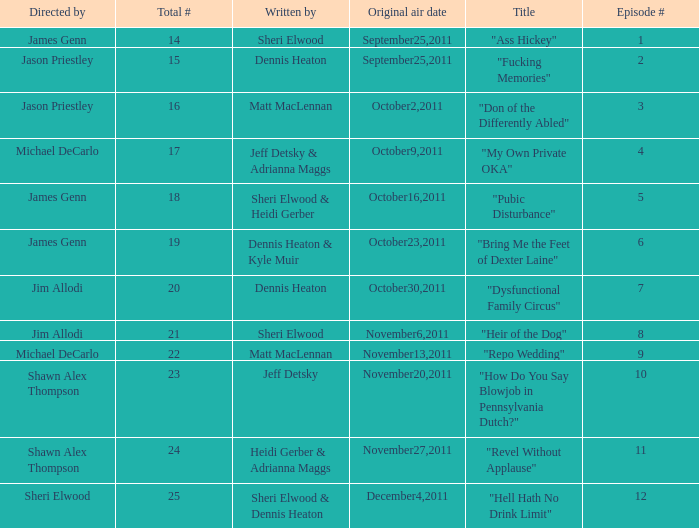How many different episode numbers does the episode written by Sheri Elwood and directed by Jim Allodi have? 1.0. 